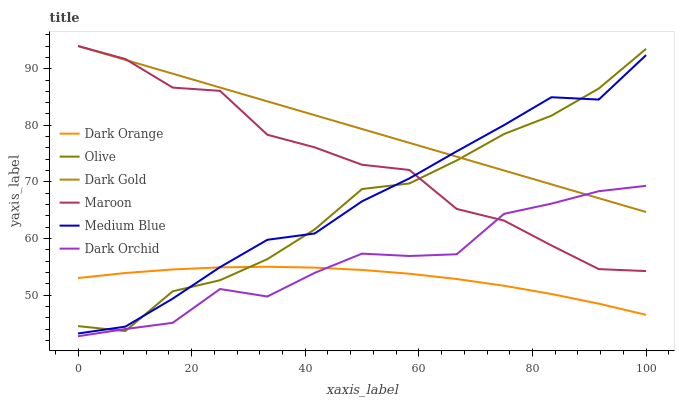Does Dark Orange have the minimum area under the curve?
Answer yes or no. Yes. Does Dark Gold have the maximum area under the curve?
Answer yes or no. Yes. Does Medium Blue have the minimum area under the curve?
Answer yes or no. No. Does Medium Blue have the maximum area under the curve?
Answer yes or no. No. Is Dark Gold the smoothest?
Answer yes or no. Yes. Is Maroon the roughest?
Answer yes or no. Yes. Is Medium Blue the smoothest?
Answer yes or no. No. Is Medium Blue the roughest?
Answer yes or no. No. Does Dark Orchid have the lowest value?
Answer yes or no. Yes. Does Medium Blue have the lowest value?
Answer yes or no. No. Does Maroon have the highest value?
Answer yes or no. Yes. Does Medium Blue have the highest value?
Answer yes or no. No. Is Dark Orange less than Dark Gold?
Answer yes or no. Yes. Is Medium Blue greater than Dark Orchid?
Answer yes or no. Yes. Does Dark Orchid intersect Maroon?
Answer yes or no. Yes. Is Dark Orchid less than Maroon?
Answer yes or no. No. Is Dark Orchid greater than Maroon?
Answer yes or no. No. Does Dark Orange intersect Dark Gold?
Answer yes or no. No. 